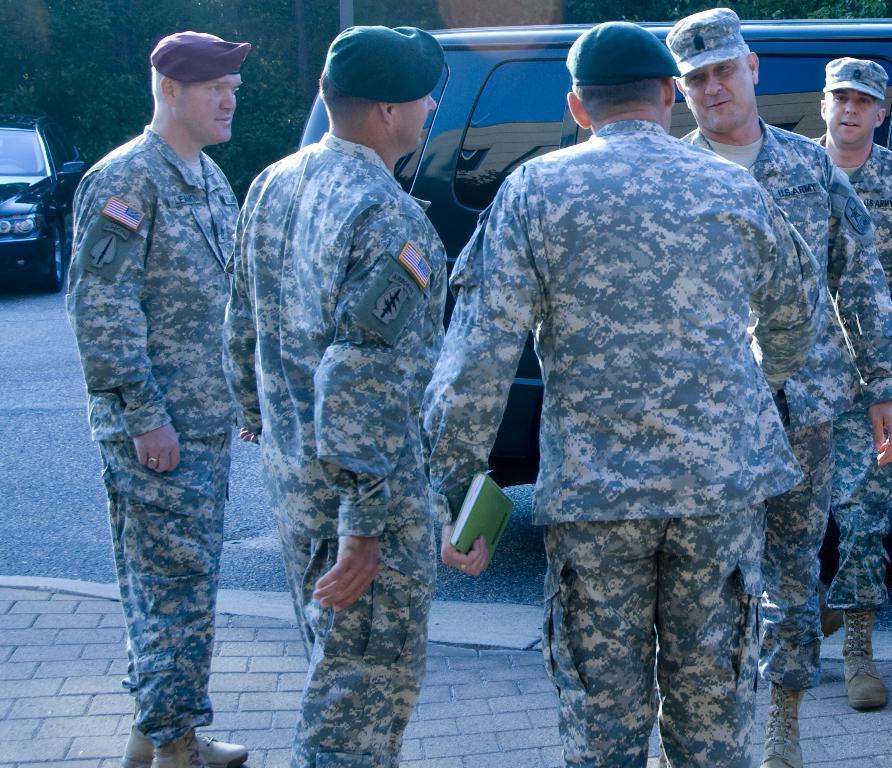Please provide a concise description of this image. In this picture we can see some people standing here, they wore caps, we can see a car on the left side, in the background we can see trees, there is a book here. 